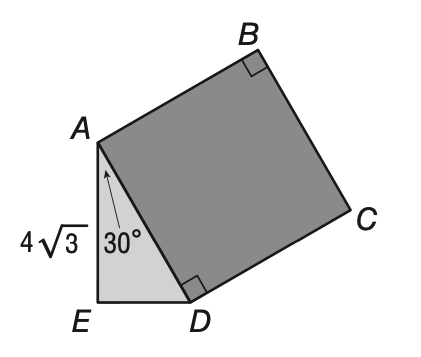Answer the mathemtical geometry problem and directly provide the correct option letter.
Question: In the figure, below, square A B C D is attached to \triangle A D E as shown. If m \angle E A D is 30 and A E is equal to 4 \sqrt { 3 }, then what is the area of square A B C D?
Choices: A: 8 \sqrt 3 B: 16 C: 64 D: 64 \sqrt 2 C 